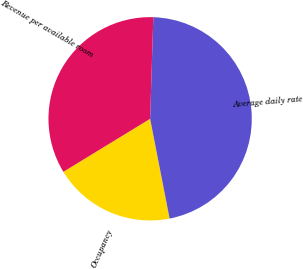<chart> <loc_0><loc_0><loc_500><loc_500><pie_chart><fcel>Occupancy<fcel>Average daily rate<fcel>Revenue per available room<nl><fcel>19.34%<fcel>46.43%<fcel>34.23%<nl></chart> 